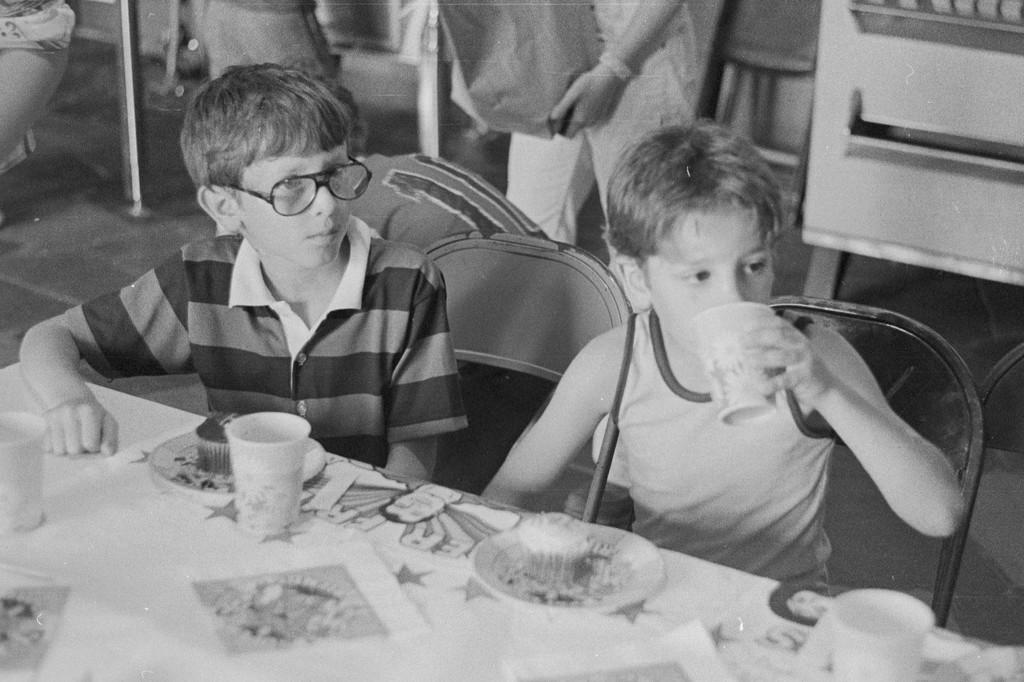How many people are in the image? There are two boys in the image. What are the boys doing in the image? The boys are sitting on a chair and having cake. What else are the boys consuming in the image? The boys are also having a cool drink. What type of trees can be seen in the background of the image? There is no background or trees visible in the image; it only features two boys sitting on a chair. 